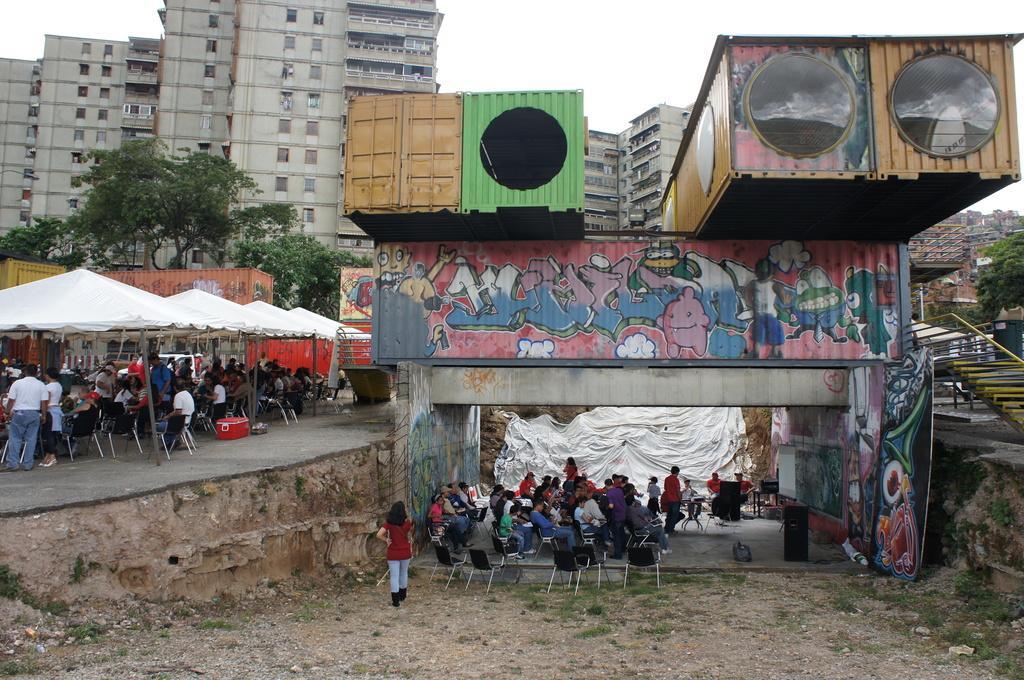How would you summarize this image in a sentence or two? In this image we can see some persons sitting on the chairs and some are standing on the ground, parasols, paintings on the containers, staircase, railings, buildings, trees and sky. 